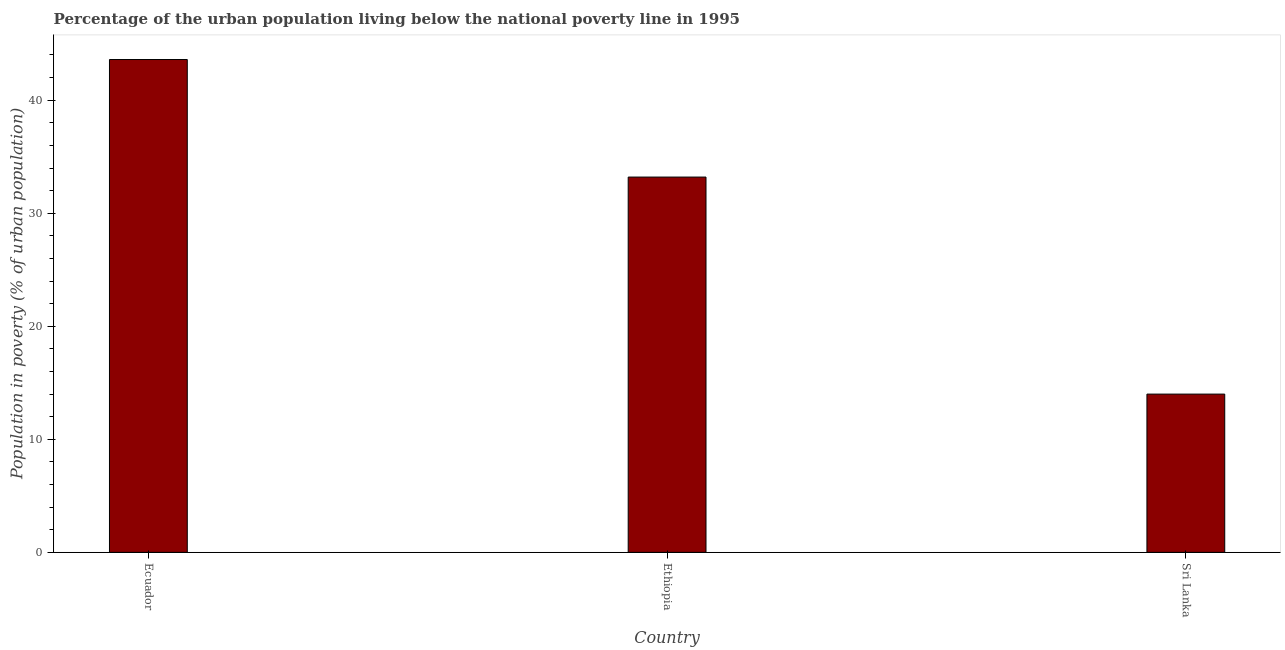Does the graph contain grids?
Your answer should be very brief. No. What is the title of the graph?
Your answer should be compact. Percentage of the urban population living below the national poverty line in 1995. What is the label or title of the Y-axis?
Offer a terse response. Population in poverty (% of urban population). What is the percentage of urban population living below poverty line in Sri Lanka?
Keep it short and to the point. 14. Across all countries, what is the maximum percentage of urban population living below poverty line?
Your answer should be very brief. 43.6. In which country was the percentage of urban population living below poverty line maximum?
Give a very brief answer. Ecuador. In which country was the percentage of urban population living below poverty line minimum?
Make the answer very short. Sri Lanka. What is the sum of the percentage of urban population living below poverty line?
Offer a very short reply. 90.8. What is the difference between the percentage of urban population living below poverty line in Ecuador and Sri Lanka?
Make the answer very short. 29.6. What is the average percentage of urban population living below poverty line per country?
Keep it short and to the point. 30.27. What is the median percentage of urban population living below poverty line?
Keep it short and to the point. 33.2. What is the ratio of the percentage of urban population living below poverty line in Ethiopia to that in Sri Lanka?
Provide a short and direct response. 2.37. Is the difference between the percentage of urban population living below poverty line in Ecuador and Sri Lanka greater than the difference between any two countries?
Your answer should be compact. Yes. Is the sum of the percentage of urban population living below poverty line in Ecuador and Ethiopia greater than the maximum percentage of urban population living below poverty line across all countries?
Your answer should be very brief. Yes. What is the difference between the highest and the lowest percentage of urban population living below poverty line?
Offer a terse response. 29.6. In how many countries, is the percentage of urban population living below poverty line greater than the average percentage of urban population living below poverty line taken over all countries?
Your response must be concise. 2. How many bars are there?
Ensure brevity in your answer.  3. Are all the bars in the graph horizontal?
Provide a succinct answer. No. Are the values on the major ticks of Y-axis written in scientific E-notation?
Make the answer very short. No. What is the Population in poverty (% of urban population) of Ecuador?
Keep it short and to the point. 43.6. What is the Population in poverty (% of urban population) of Ethiopia?
Your answer should be compact. 33.2. What is the difference between the Population in poverty (% of urban population) in Ecuador and Ethiopia?
Offer a terse response. 10.4. What is the difference between the Population in poverty (% of urban population) in Ecuador and Sri Lanka?
Your answer should be compact. 29.6. What is the ratio of the Population in poverty (% of urban population) in Ecuador to that in Ethiopia?
Your response must be concise. 1.31. What is the ratio of the Population in poverty (% of urban population) in Ecuador to that in Sri Lanka?
Provide a short and direct response. 3.11. What is the ratio of the Population in poverty (% of urban population) in Ethiopia to that in Sri Lanka?
Provide a short and direct response. 2.37. 